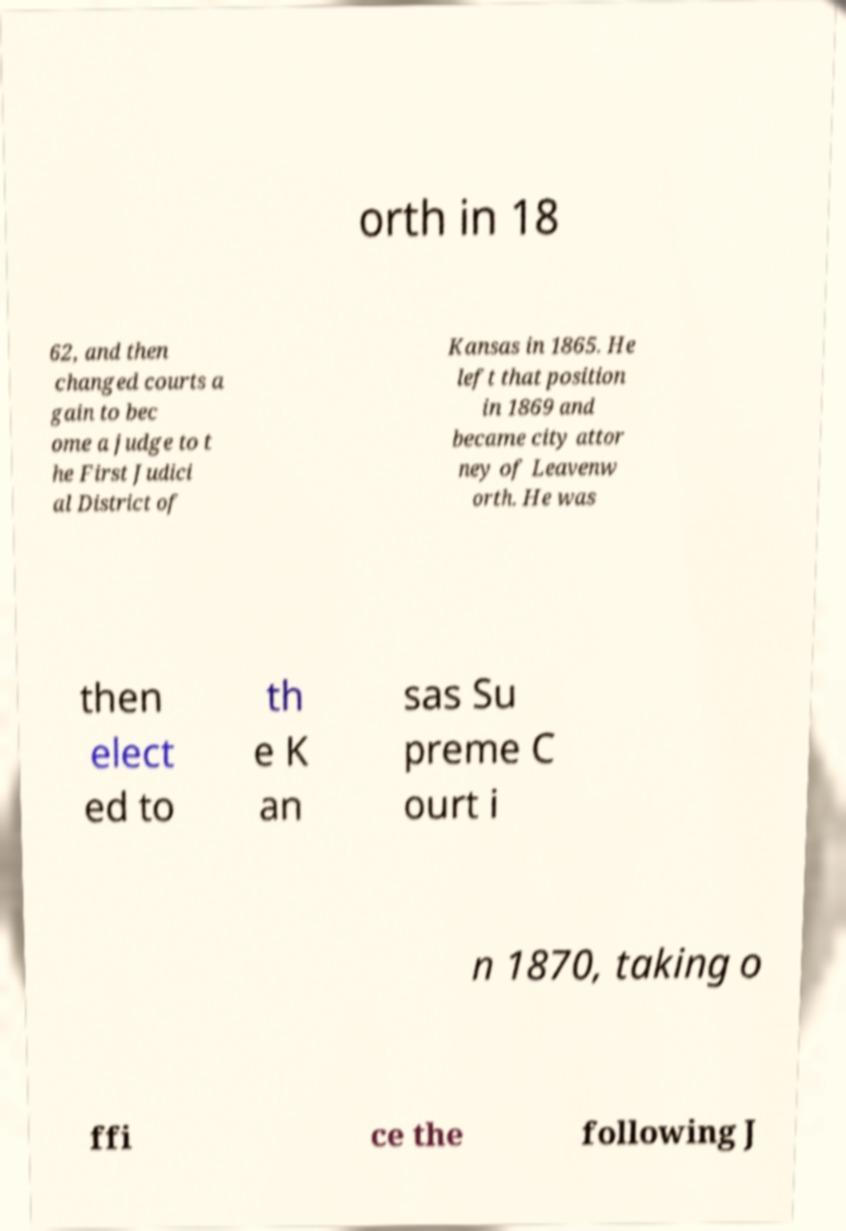There's text embedded in this image that I need extracted. Can you transcribe it verbatim? orth in 18 62, and then changed courts a gain to bec ome a judge to t he First Judici al District of Kansas in 1865. He left that position in 1869 and became city attor ney of Leavenw orth. He was then elect ed to th e K an sas Su preme C ourt i n 1870, taking o ffi ce the following J 